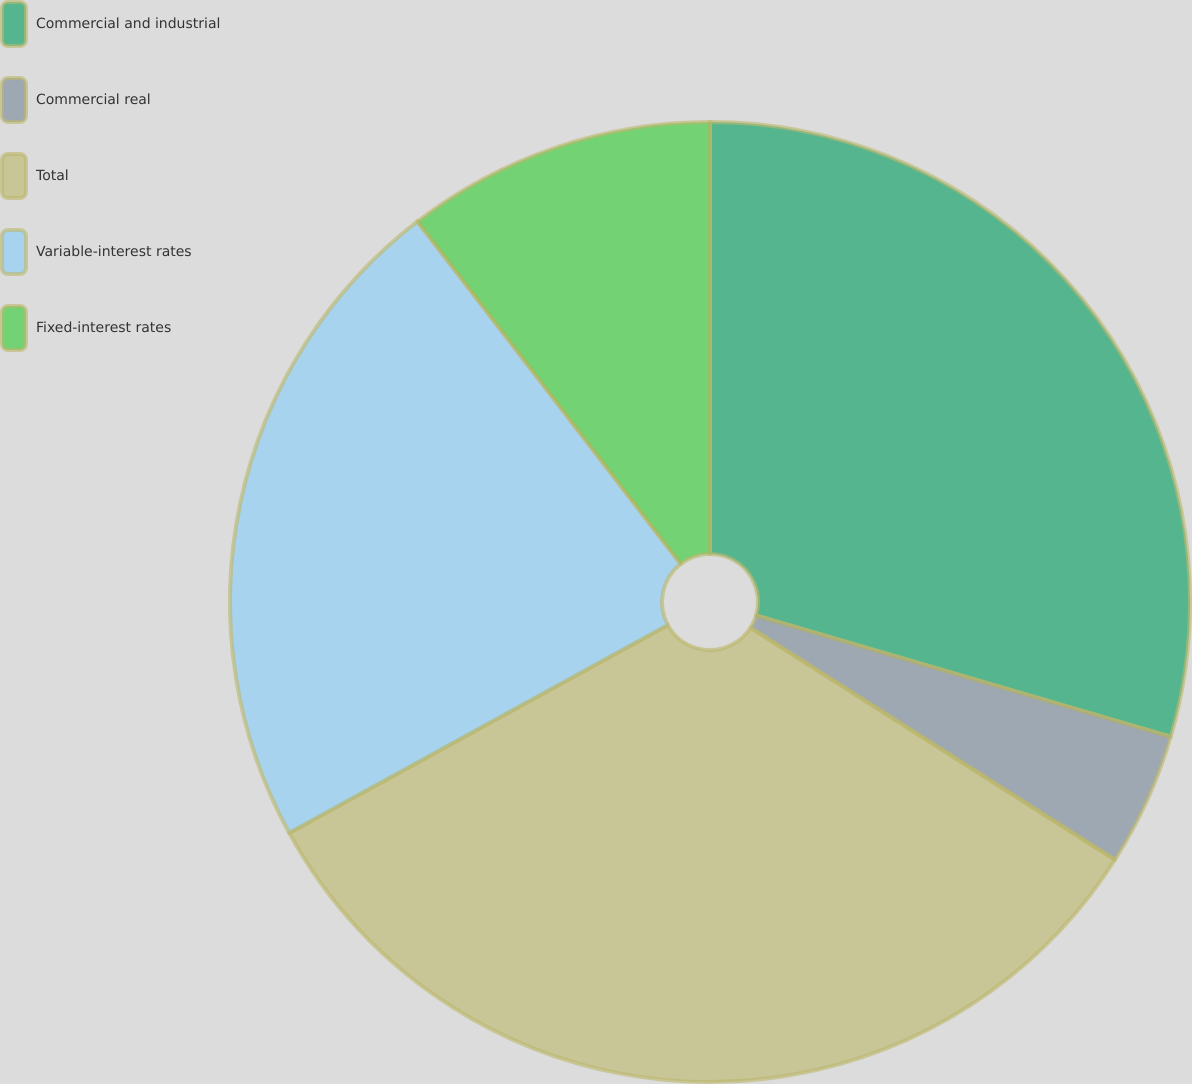Convert chart. <chart><loc_0><loc_0><loc_500><loc_500><pie_chart><fcel>Commercial and industrial<fcel>Commercial real<fcel>Total<fcel>Variable-interest rates<fcel>Fixed-interest rates<nl><fcel>29.53%<fcel>4.49%<fcel>32.99%<fcel>22.56%<fcel>10.43%<nl></chart> 